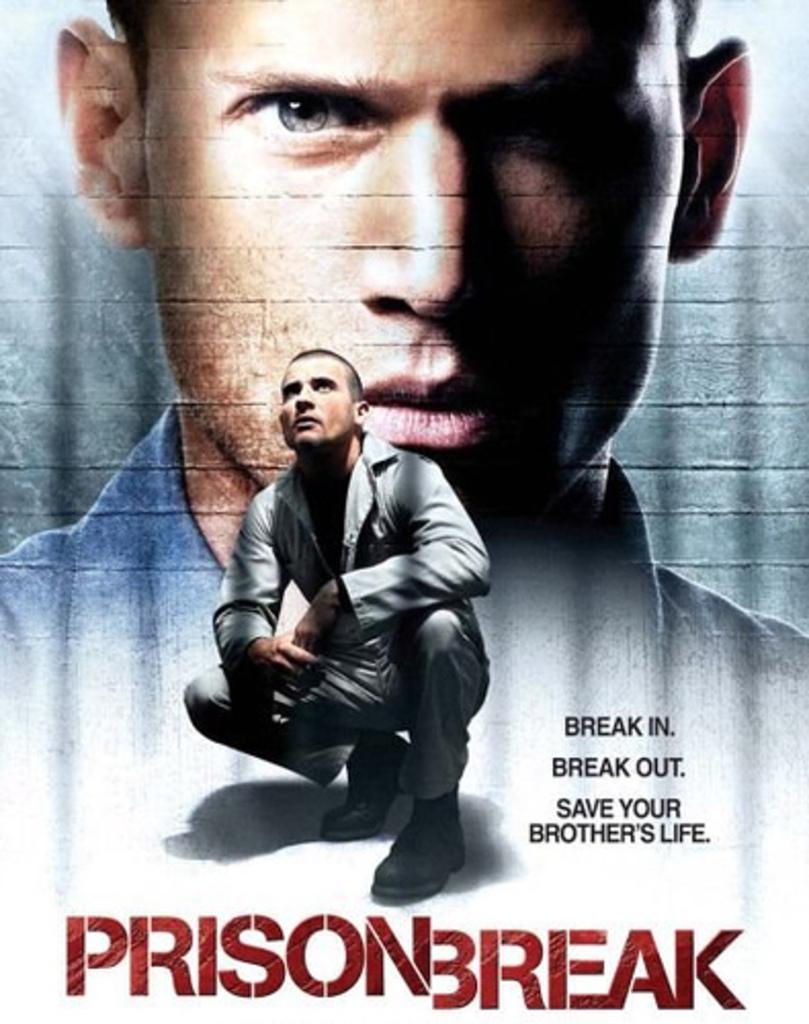How would you summarize this image in a sentence or two? In this image we can see a poster with two persons and some text written on it. 